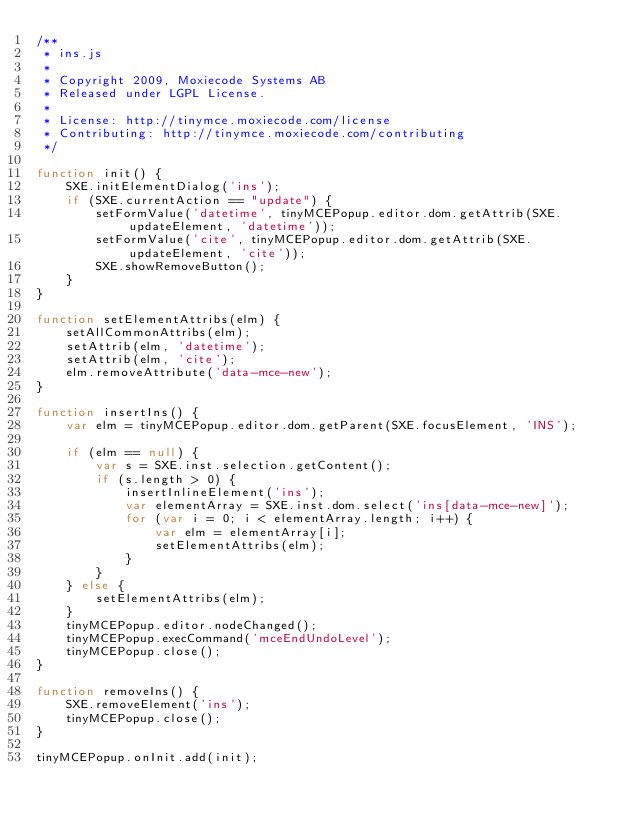<code> <loc_0><loc_0><loc_500><loc_500><_JavaScript_>/**
 * ins.js
 *
 * Copyright 2009, Moxiecode Systems AB
 * Released under LGPL License.
 *
 * License: http://tinymce.moxiecode.com/license
 * Contributing: http://tinymce.moxiecode.com/contributing
 */

function init() {
    SXE.initElementDialog('ins');
    if (SXE.currentAction == "update") {
        setFormValue('datetime', tinyMCEPopup.editor.dom.getAttrib(SXE.updateElement, 'datetime'));
        setFormValue('cite', tinyMCEPopup.editor.dom.getAttrib(SXE.updateElement, 'cite'));
        SXE.showRemoveButton();
    }
}

function setElementAttribs(elm) {
    setAllCommonAttribs(elm);
    setAttrib(elm, 'datetime');
    setAttrib(elm, 'cite');
    elm.removeAttribute('data-mce-new');
}

function insertIns() {
    var elm = tinyMCEPopup.editor.dom.getParent(SXE.focusElement, 'INS');

    if (elm == null) {
        var s = SXE.inst.selection.getContent();
        if (s.length > 0) {
            insertInlineElement('ins');
            var elementArray = SXE.inst.dom.select('ins[data-mce-new]');
            for (var i = 0; i < elementArray.length; i++) {
                var elm = elementArray[i];
                setElementAttribs(elm);
            }
        }
    } else {
        setElementAttribs(elm);
    }
    tinyMCEPopup.editor.nodeChanged();
    tinyMCEPopup.execCommand('mceEndUndoLevel');
    tinyMCEPopup.close();
}

function removeIns() {
    SXE.removeElement('ins');
    tinyMCEPopup.close();
}

tinyMCEPopup.onInit.add(init);
</code> 